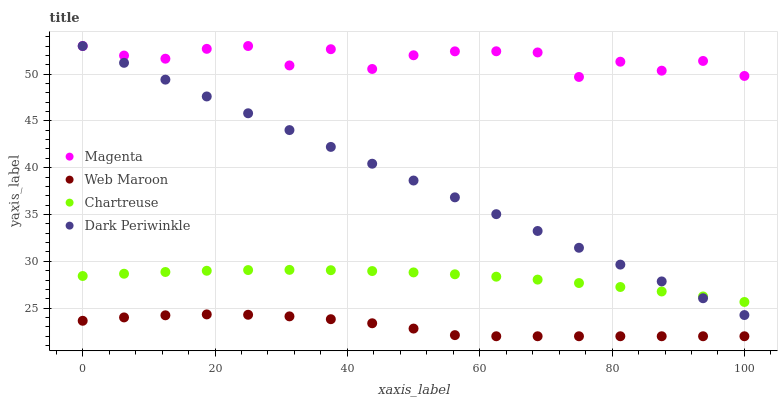Does Web Maroon have the minimum area under the curve?
Answer yes or no. Yes. Does Magenta have the maximum area under the curve?
Answer yes or no. Yes. Does Chartreuse have the minimum area under the curve?
Answer yes or no. No. Does Chartreuse have the maximum area under the curve?
Answer yes or no. No. Is Dark Periwinkle the smoothest?
Answer yes or no. Yes. Is Magenta the roughest?
Answer yes or no. Yes. Is Web Maroon the smoothest?
Answer yes or no. No. Is Web Maroon the roughest?
Answer yes or no. No. Does Web Maroon have the lowest value?
Answer yes or no. Yes. Does Chartreuse have the lowest value?
Answer yes or no. No. Does Dark Periwinkle have the highest value?
Answer yes or no. Yes. Does Chartreuse have the highest value?
Answer yes or no. No. Is Web Maroon less than Dark Periwinkle?
Answer yes or no. Yes. Is Chartreuse greater than Web Maroon?
Answer yes or no. Yes. Does Magenta intersect Dark Periwinkle?
Answer yes or no. Yes. Is Magenta less than Dark Periwinkle?
Answer yes or no. No. Is Magenta greater than Dark Periwinkle?
Answer yes or no. No. Does Web Maroon intersect Dark Periwinkle?
Answer yes or no. No. 